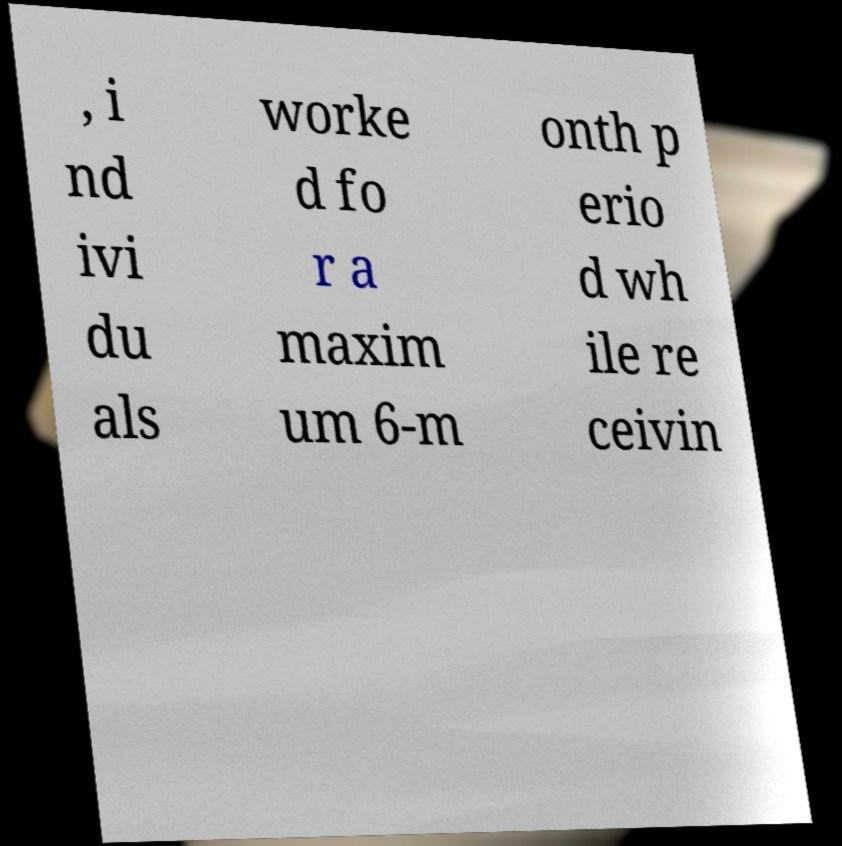Could you extract and type out the text from this image? , i nd ivi du als worke d fo r a maxim um 6-m onth p erio d wh ile re ceivin 